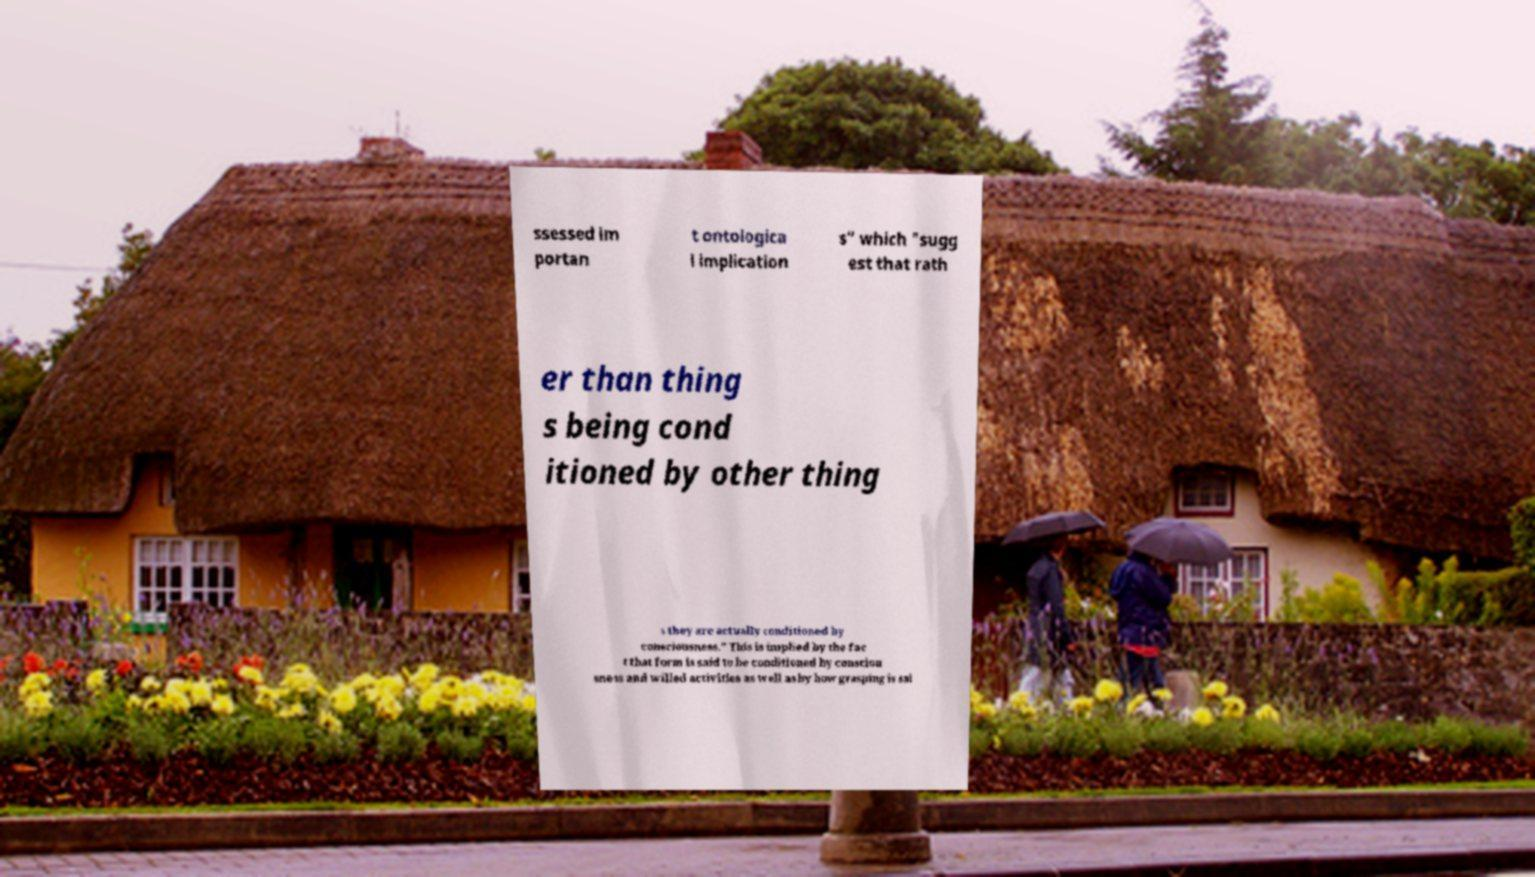I need the written content from this picture converted into text. Can you do that? ssessed im portan t ontologica l implication s" which "sugg est that rath er than thing s being cond itioned by other thing s they are actually conditioned by consciousness." This is implied by the fac t that form is said to be conditioned by consciou sness and willed activities as well as by how grasping is sai 